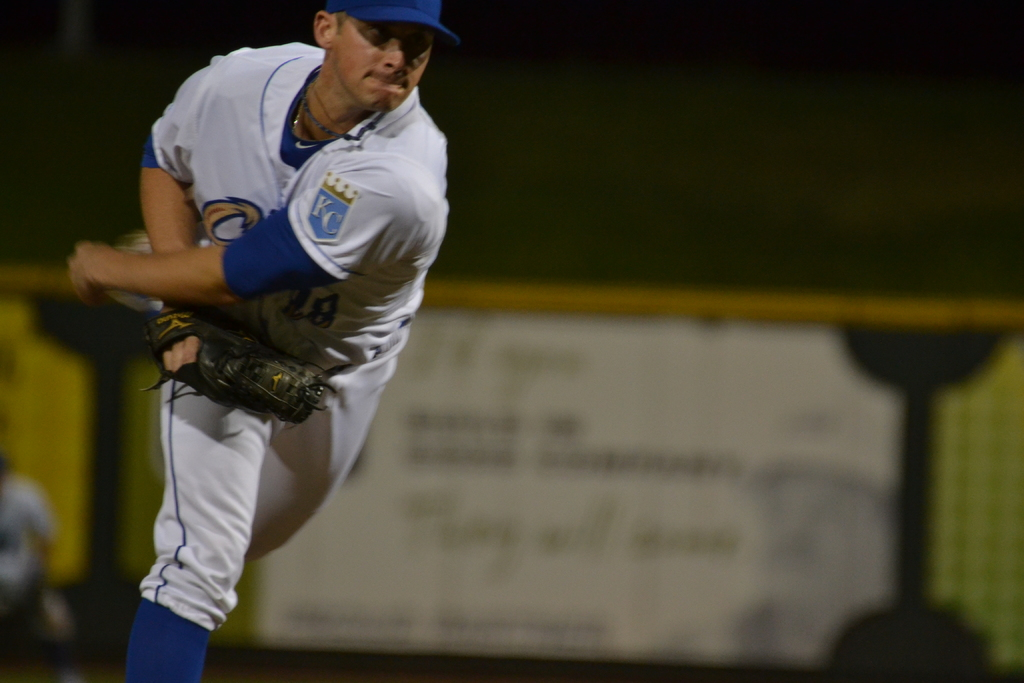Provide a one-sentence caption for the provided image. A focused baseball pitcher, dressed in a white KC uniform, intensely delivers a pitch during a night game, his expression concentrated and determined. 